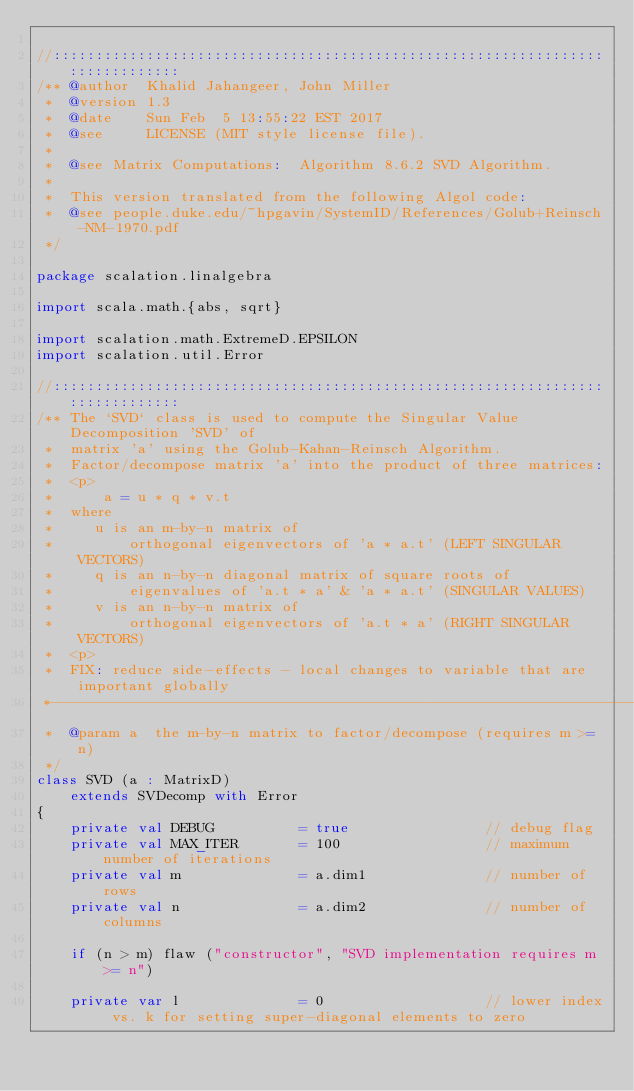<code> <loc_0><loc_0><loc_500><loc_500><_Scala_>
//::::::::::::::::::::::::::::::::::::::::::::::::::::::::::::::::::::::::::::::
/** @author  Khalid Jahangeer, John Miller
 *  @version 1.3
 *  @date    Sun Feb  5 13:55:22 EST 2017
 *  @see     LICENSE (MIT style license file).
 *
 *  @see Matrix Computations:  Algorithm 8.6.2 SVD Algorithm.
 *
 *  This version translated from the following Algol code:
 *  @see people.duke.edu/~hpgavin/SystemID/References/Golub+Reinsch-NM-1970.pdf
 */

package scalation.linalgebra

import scala.math.{abs, sqrt}

import scalation.math.ExtremeD.EPSILON
import scalation.util.Error

//::::::::::::::::::::::::::::::::::::::::::::::::::::::::::::::::::::::::::::::
/** The `SVD` class is used to compute the Singular Value Decomposition 'SVD' of
 *  matrix 'a' using the Golub-Kahan-Reinsch Algorithm.
 *  Factor/decompose matrix 'a' into the product of three matrices:
 *  <p>
 *      a = u * q * v.t
 *  where
 *     u is an m-by-n matrix of
 *         orthogonal eigenvectors of 'a * a.t' (LEFT SINGULAR VECTORS)
 *     q is an n-by-n diagonal matrix of square roots of
 *         eigenvalues of 'a.t * a' & 'a * a.t' (SINGULAR VALUES)
 *     v is an n-by-n matrix of
 *         orthogonal eigenvectors of 'a.t * a' (RIGHT SINGULAR VECTORS)
 *  <p>
 *  FIX: reduce side-effects - local changes to variable that are important globally
 *------------------------------------------------------------------------------
 *  @param a  the m-by-n matrix to factor/decompose (requires m >= n)
 */
class SVD (a : MatrixD)
    extends SVDecomp with Error
{
    private val DEBUG          = true                // debug flag
    private val MAX_ITER       = 100                 // maximum number of iterations
    private val m              = a.dim1              // number of rows
    private val n              = a.dim2              // number of columns

    if (n > m) flaw ("constructor", "SVD implementation requires m >= n")

    private var l              = 0                   // lower index vs. k for setting super-diagonal elements to zero</code> 